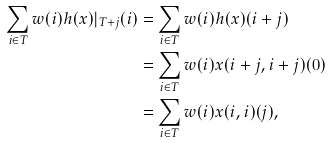<formula> <loc_0><loc_0><loc_500><loc_500>\sum _ { i \in T } w ( i ) h ( x ) | _ { T + j } ( i ) & = \sum _ { i \in T } w ( i ) h ( x ) ( i + j ) \\ & = \sum _ { i \in T } w ( i ) x ( i + j , i + j ) ( 0 ) \\ & = \sum _ { i \in T } w ( i ) x ( i , i ) ( j ) ,</formula> 